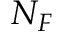<formula> <loc_0><loc_0><loc_500><loc_500>N _ { F }</formula> 